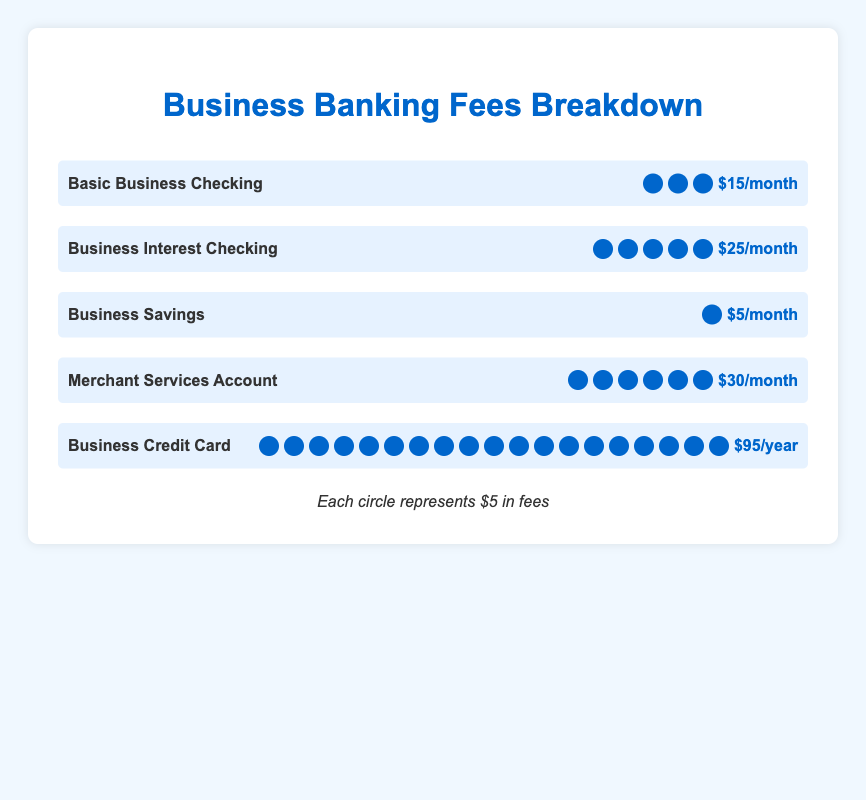What is the monthly fee for the Basic Business Checking account? According to the figure, the Basic Business Checking account is represented with 3 fee icons, each indicating $5, totaling a fee of $15 per month, explicitly mentioned beside those icons.
Answer: $15/month How many fee units are represented for the Business Savings account? The Business Savings account section in the plot shows one fee icon, and each icon represents $5. Hence, this account has 1 fee unit.
Answer: 1 Which account type has the highest monthly fee? The Merchant Services Account, represented with 6 fee icons, each standing for $5, sums up to $30 per month, which is the highest among the listed account types.
Answer: Merchant Services Account What is the annual fee for the Business Credit Card? The Business Credit Card section shows 19 fee icons, each representing $5. Multiplying 19 by 5 gives the total annual fee of $95, which is also directly mentioned beside the icons.
Answer: $95/year Compare the fee of Business Interest Checking and Business Savings accounts. Which one is higher, and by how much? The Business Interest Checking account has 5 fee icons ($25/month) while the Business Savings account has 1 fee icon ($5/month). The difference is $25 - $5 = $20. Therefore, the checking account fee is $20 higher.
Answer: Business Interest Checking by $20/month What is the total monthly fee for Basic Business Checking and Business Interest Checking accounts combined? The Basic Business Checking account fee is $15/month (3 fee icons) and the Business Interest Checking account fee is $25/month (5 fee icons). Adding them together gives $15 + $25 = $40.
Answer: $40/month How many total fee units are represented across all account types? Basic Business Checking: 3, Business Interest Checking: 5, Business Savings: 1, Merchant Services Account: 6, Business Credit Card: 19. Summing them up, 3 + 5 + 1 + 6 + 19 = 34 fee units.
Answer: 34 What percentage of the total fee units does the Business Credit Card account for? The Business Credit Card has 19 fee units out of a total of 34. To find the percentage, divide 19 by 34 and multiply by 100: (19/34) * 100 ≈ 55.88%.
Answer: ≈55.88% 